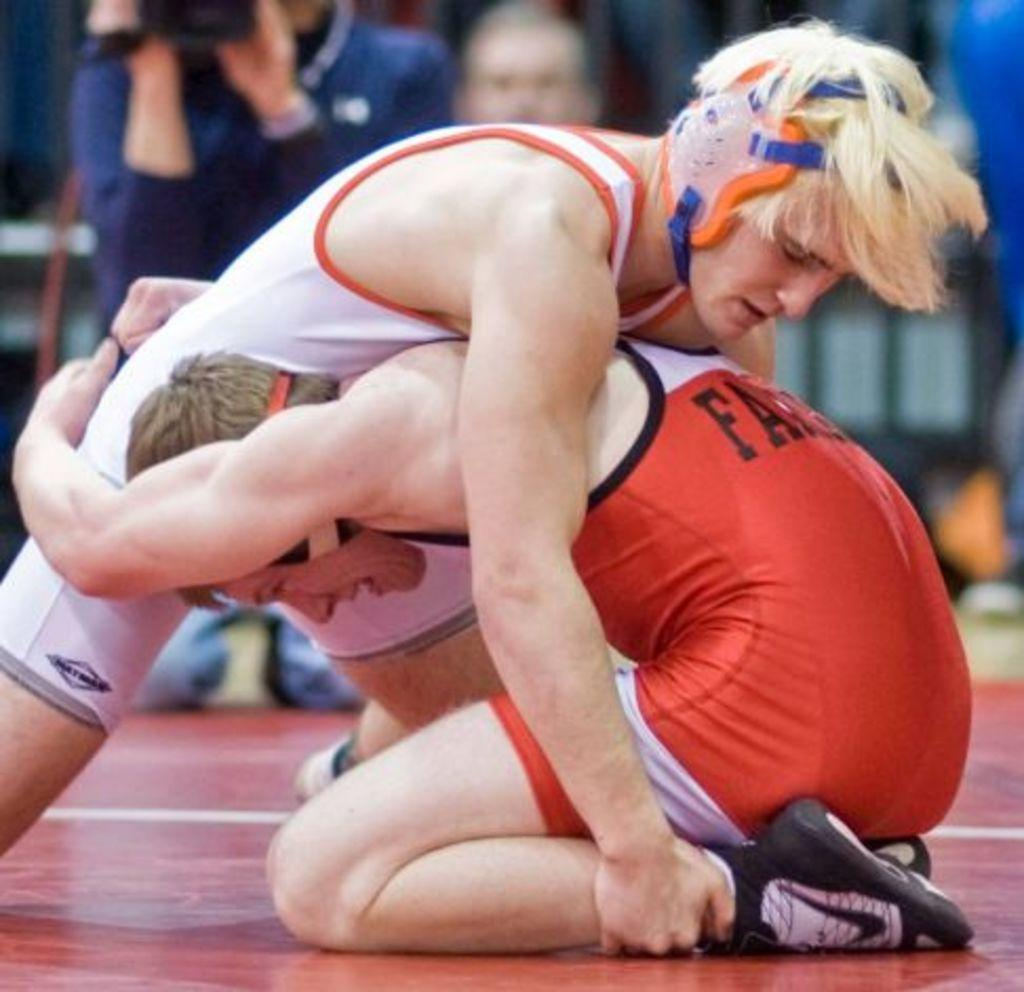<image>
Create a compact narrative representing the image presented. Two wrestlers wrestling, one with the letters FA written on the back. 